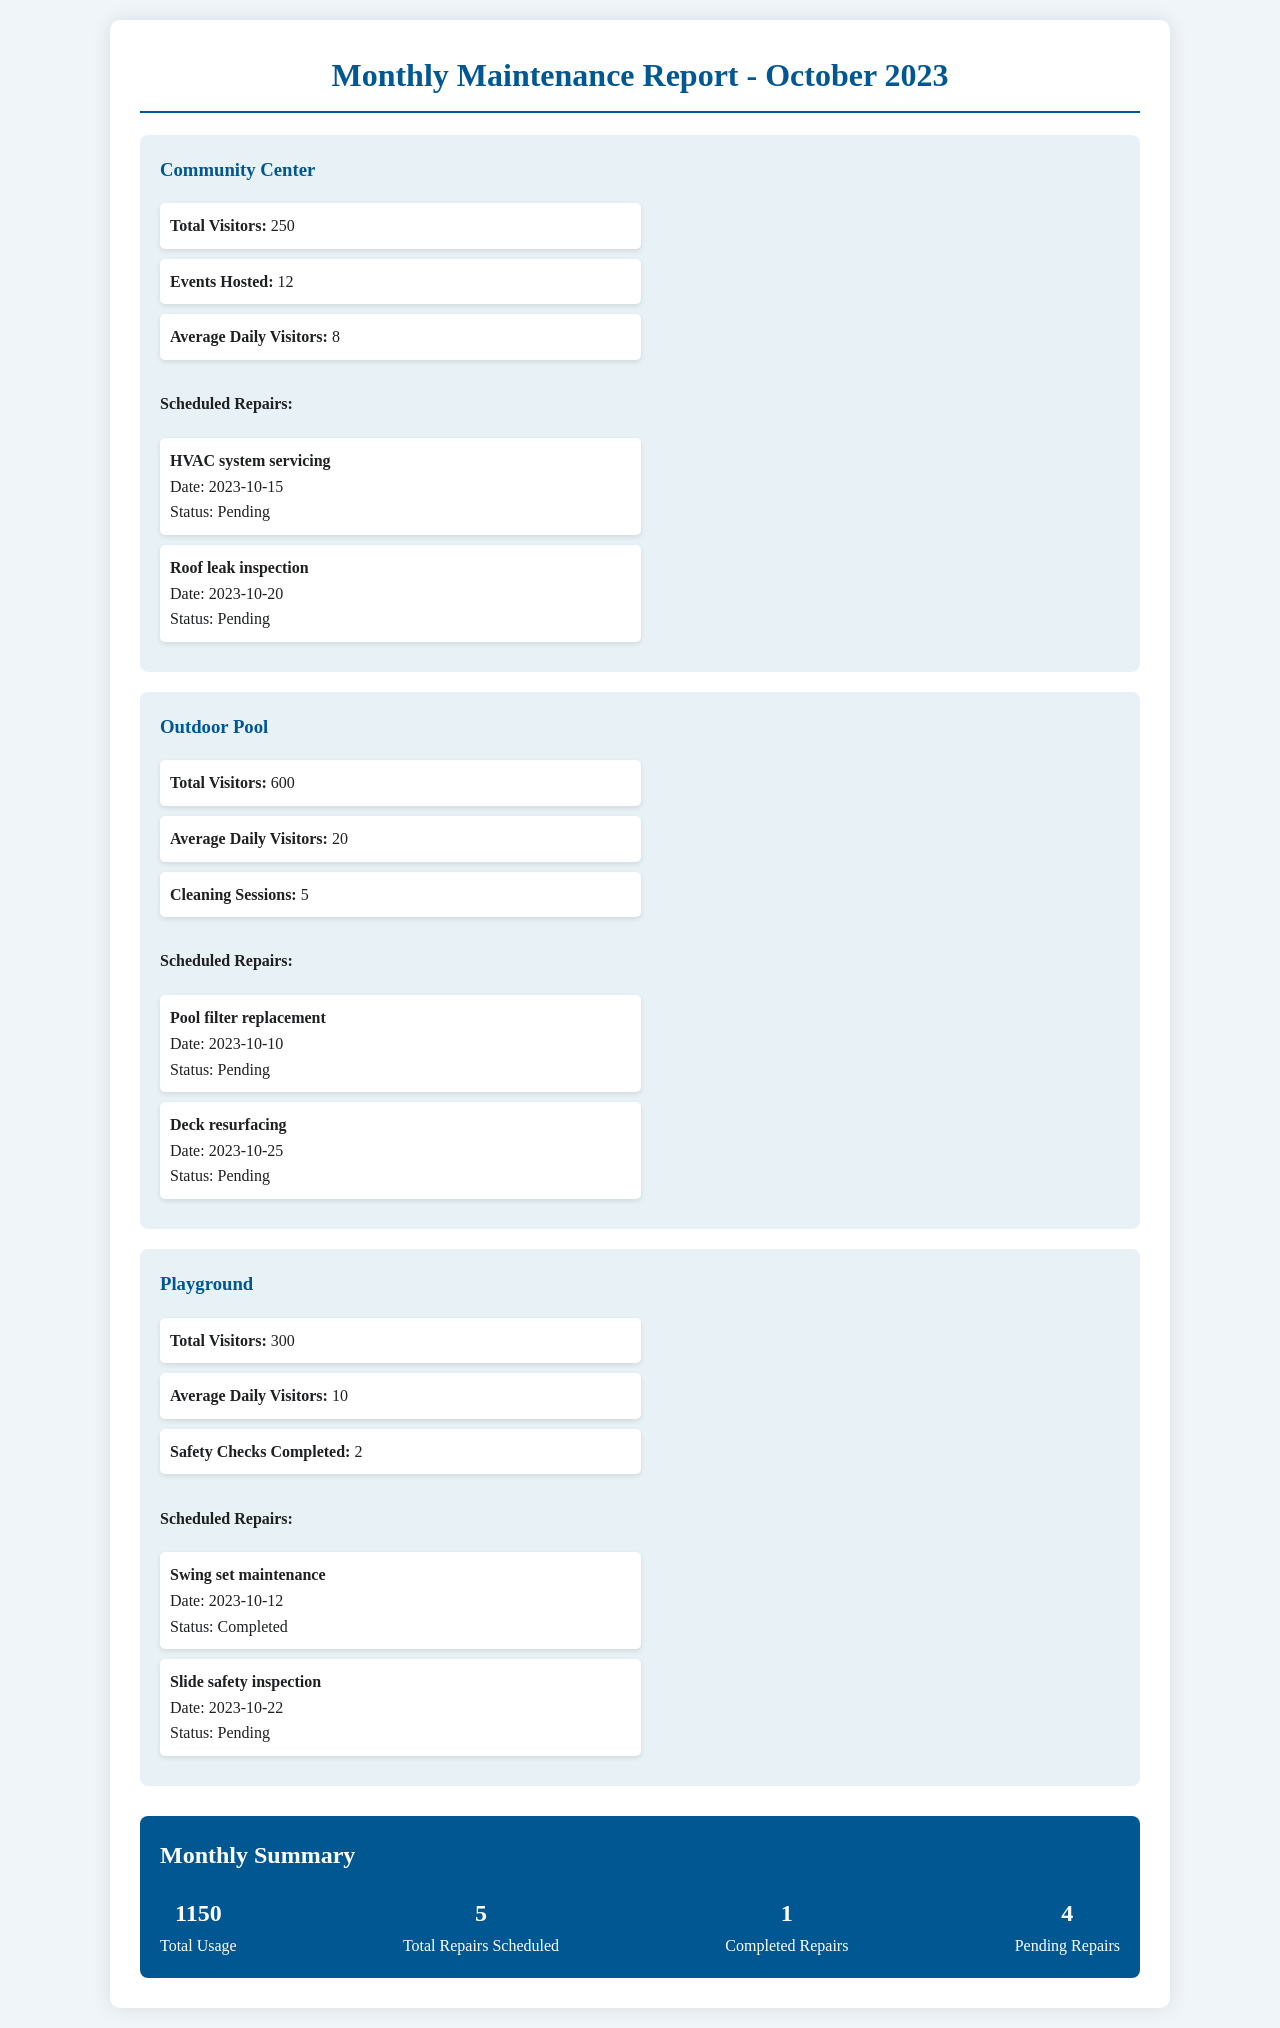What is the total number of visitors to the Outdoor Pool? The total number of visitors is specifically stated for the Outdoor Pool as 600.
Answer: 600 When is the scheduled inspection for the slide safety? The scheduled inspection date for the slide safety is mentioned in the Playground section as October 22, 2023.
Answer: 2023-10-22 How many events were hosted at the Community Center? The number of events hosted at the Community Center is clearly listed as 12.
Answer: 12 What is the status of the HVAC system servicing? The status for the HVAC system servicing is indicated as Pending in the report.
Answer: Pending What is the total usage across all facilities? The total usage is summarized in the monthly summary as 1150.
Answer: 1150 How many repairs are pending according to the report? The document states there are 4 pending repairs in the monthly summary.
Answer: 4 Which facility had completed maintenance on the swing set? The document indicates that the swing set maintenance has been completed in the Playground section.
Answer: Playground What was the average daily visitor count for the Community Center? The average daily visitors for the Community Center are given as 8.
Answer: 8 